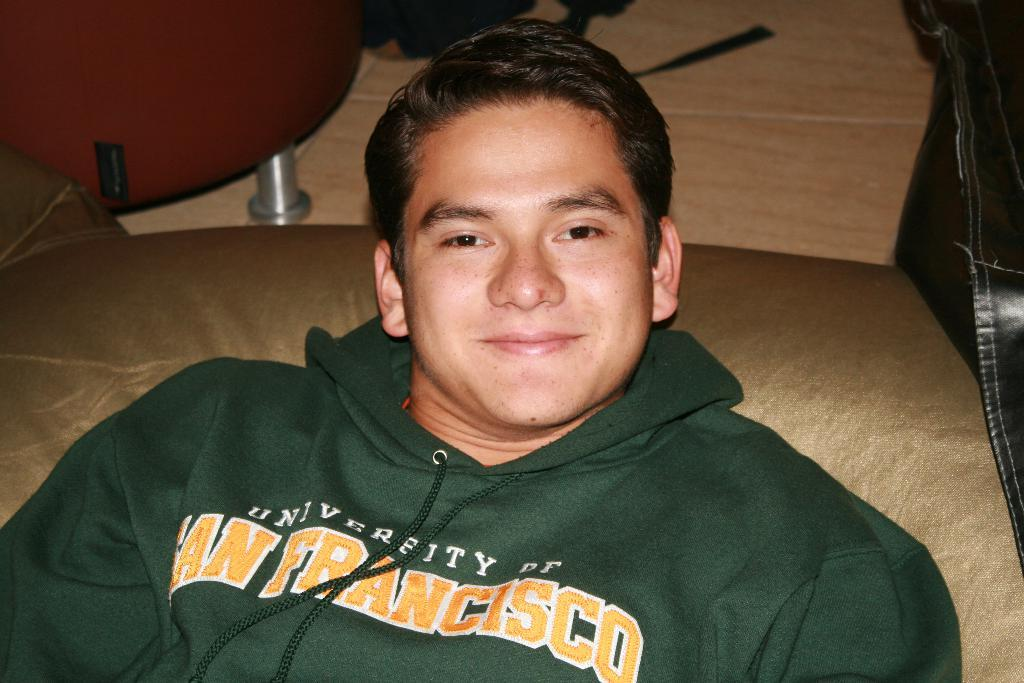Provide a one-sentence caption for the provided image. A young man wears a green University of San Francisco sweatshirt. 